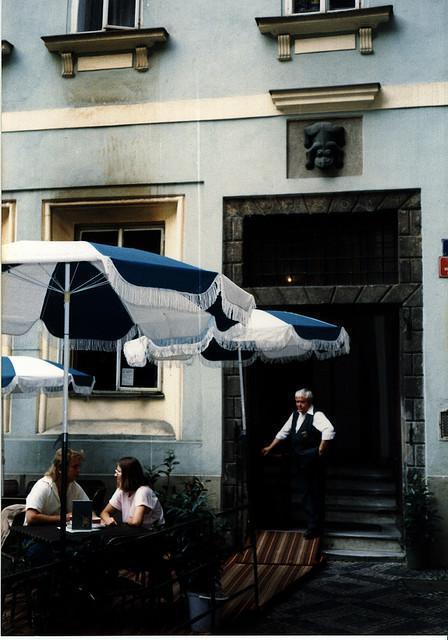How many umbrellas are in the photo?
Give a very brief answer. 3. How many people are there?
Give a very brief answer. 3. 